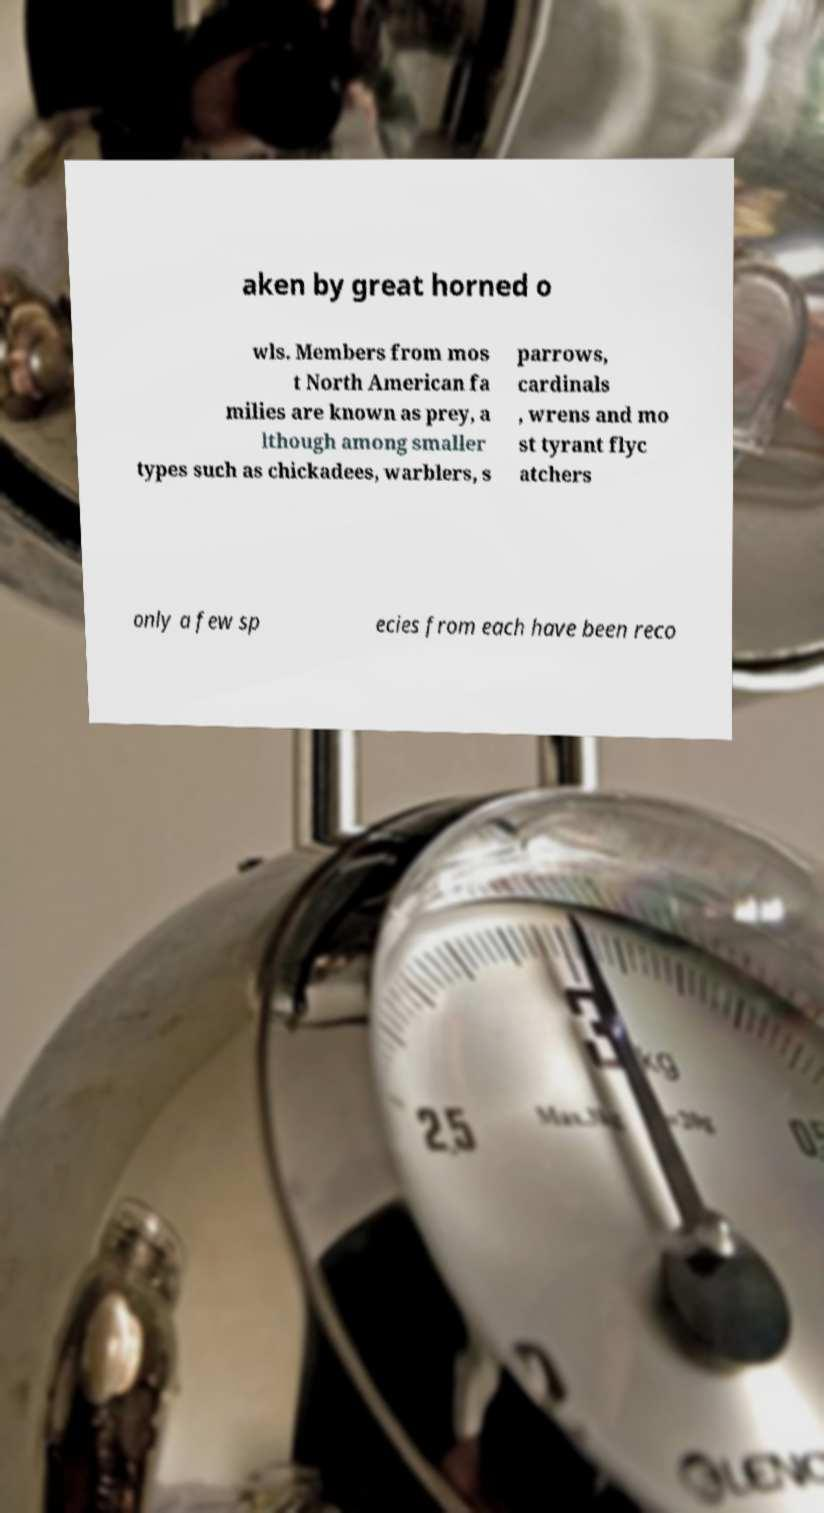For documentation purposes, I need the text within this image transcribed. Could you provide that? aken by great horned o wls. Members from mos t North American fa milies are known as prey, a lthough among smaller types such as chickadees, warblers, s parrows, cardinals , wrens and mo st tyrant flyc atchers only a few sp ecies from each have been reco 